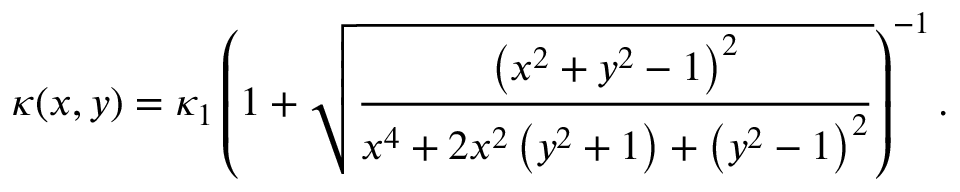<formula> <loc_0><loc_0><loc_500><loc_500>\kappa ( x , y ) = \kappa _ { 1 } \left ( 1 + \sqrt { \frac { \left ( x ^ { 2 } + y ^ { 2 } - 1 \right ) ^ { 2 } } { { x ^ { 4 } + 2 x ^ { 2 } \left ( y ^ { 2 } + 1 \right ) + \left ( y ^ { 2 } - 1 \right ) ^ { 2 } } } } \right ) ^ { - 1 } .</formula> 